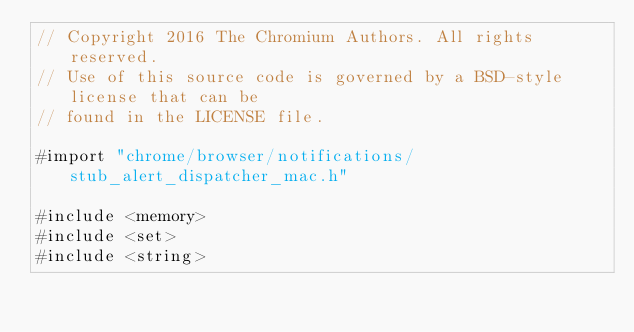<code> <loc_0><loc_0><loc_500><loc_500><_ObjectiveC_>// Copyright 2016 The Chromium Authors. All rights reserved.
// Use of this source code is governed by a BSD-style license that can be
// found in the LICENSE file.

#import "chrome/browser/notifications/stub_alert_dispatcher_mac.h"

#include <memory>
#include <set>
#include <string></code> 